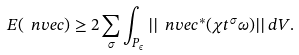<formula> <loc_0><loc_0><loc_500><loc_500>E ( \ n v e c ) \geq 2 \sum _ { \sigma } \int _ { P _ { \epsilon } } | | \ n v e c ^ { * } ( \chi t ^ { \sigma } \omega ) | | \, d V .</formula> 